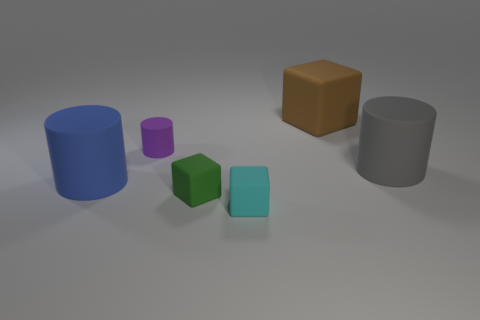Add 3 small green blocks. How many objects exist? 9 Subtract 0 blue cubes. How many objects are left? 6 Subtract all large rubber things. Subtract all blue rubber cylinders. How many objects are left? 2 Add 4 small purple cylinders. How many small purple cylinders are left? 5 Add 2 tiny brown balls. How many tiny brown balls exist? 2 